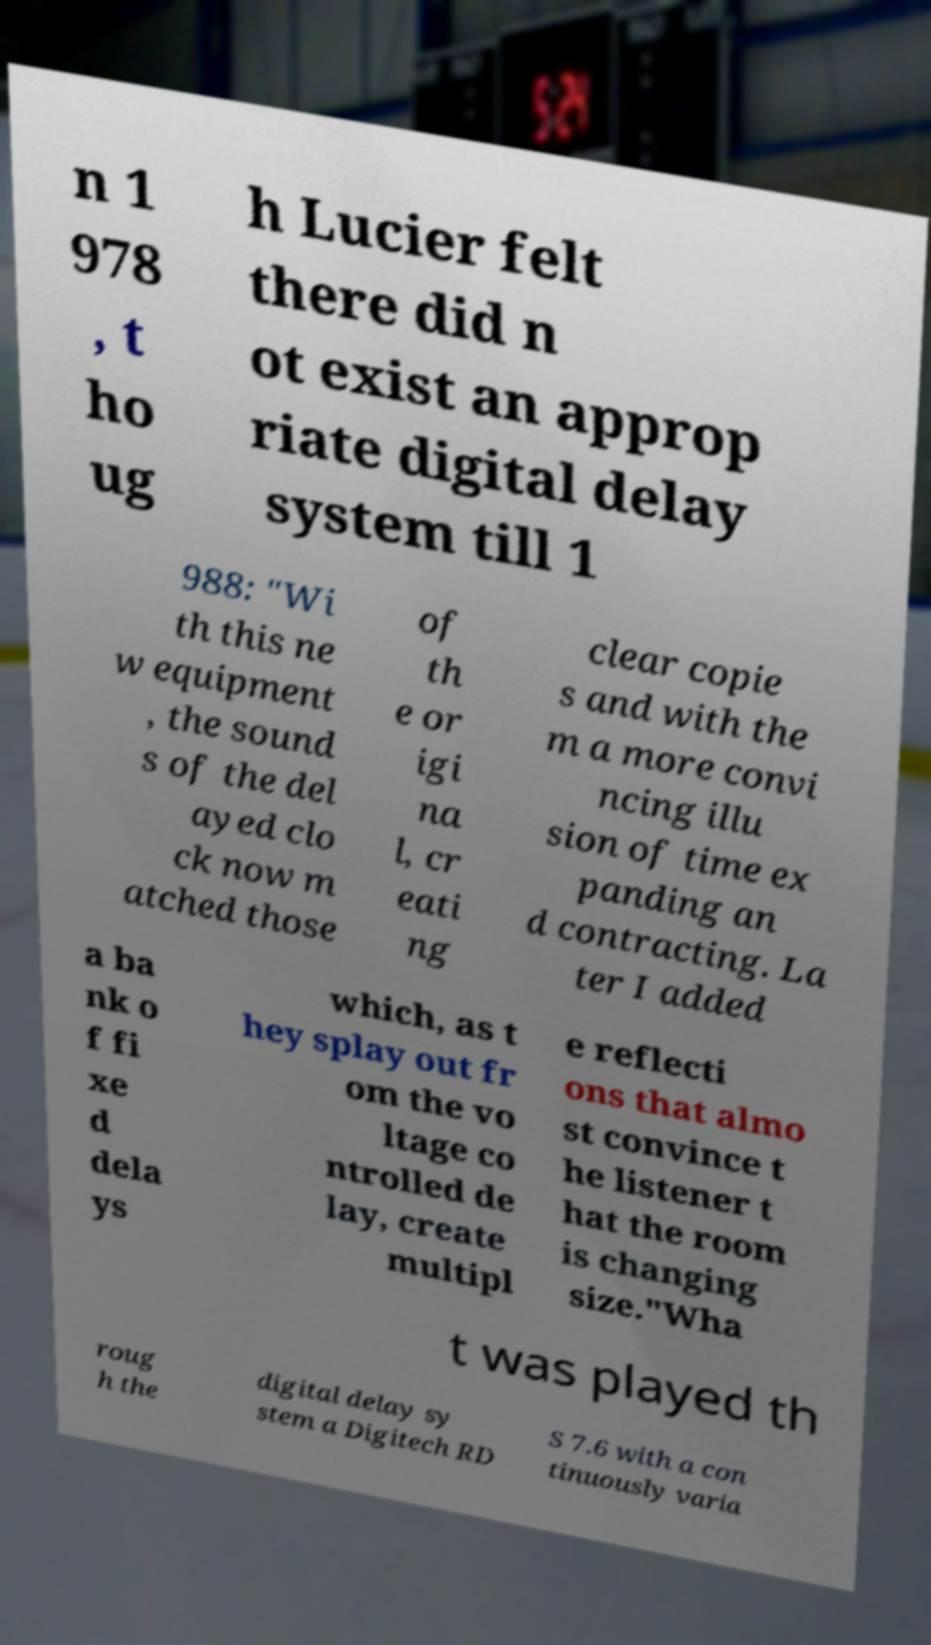Can you accurately transcribe the text from the provided image for me? n 1 978 , t ho ug h Lucier felt there did n ot exist an approp riate digital delay system till 1 988: "Wi th this ne w equipment , the sound s of the del ayed clo ck now m atched those of th e or igi na l, cr eati ng clear copie s and with the m a more convi ncing illu sion of time ex panding an d contracting. La ter I added a ba nk o f fi xe d dela ys which, as t hey splay out fr om the vo ltage co ntrolled de lay, create multipl e reflecti ons that almo st convince t he listener t hat the room is changing size."Wha t was played th roug h the digital delay sy stem a Digitech RD S 7.6 with a con tinuously varia 